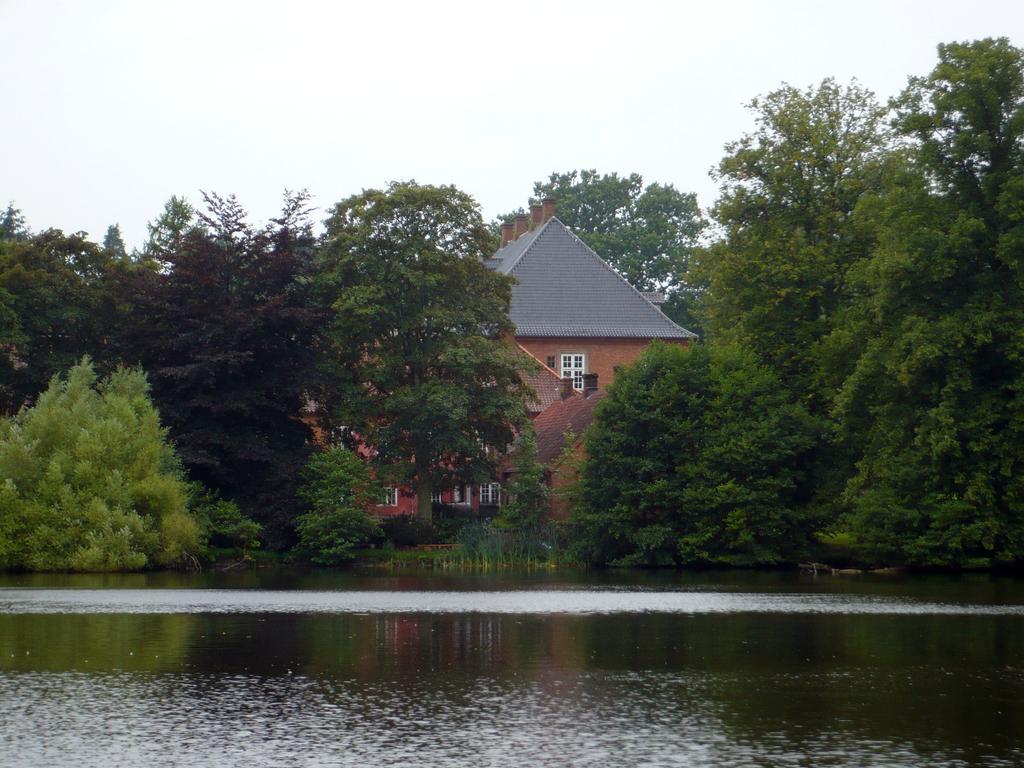Please provide a concise description of this image. In this image there is a river, trees, a house and the sky. 